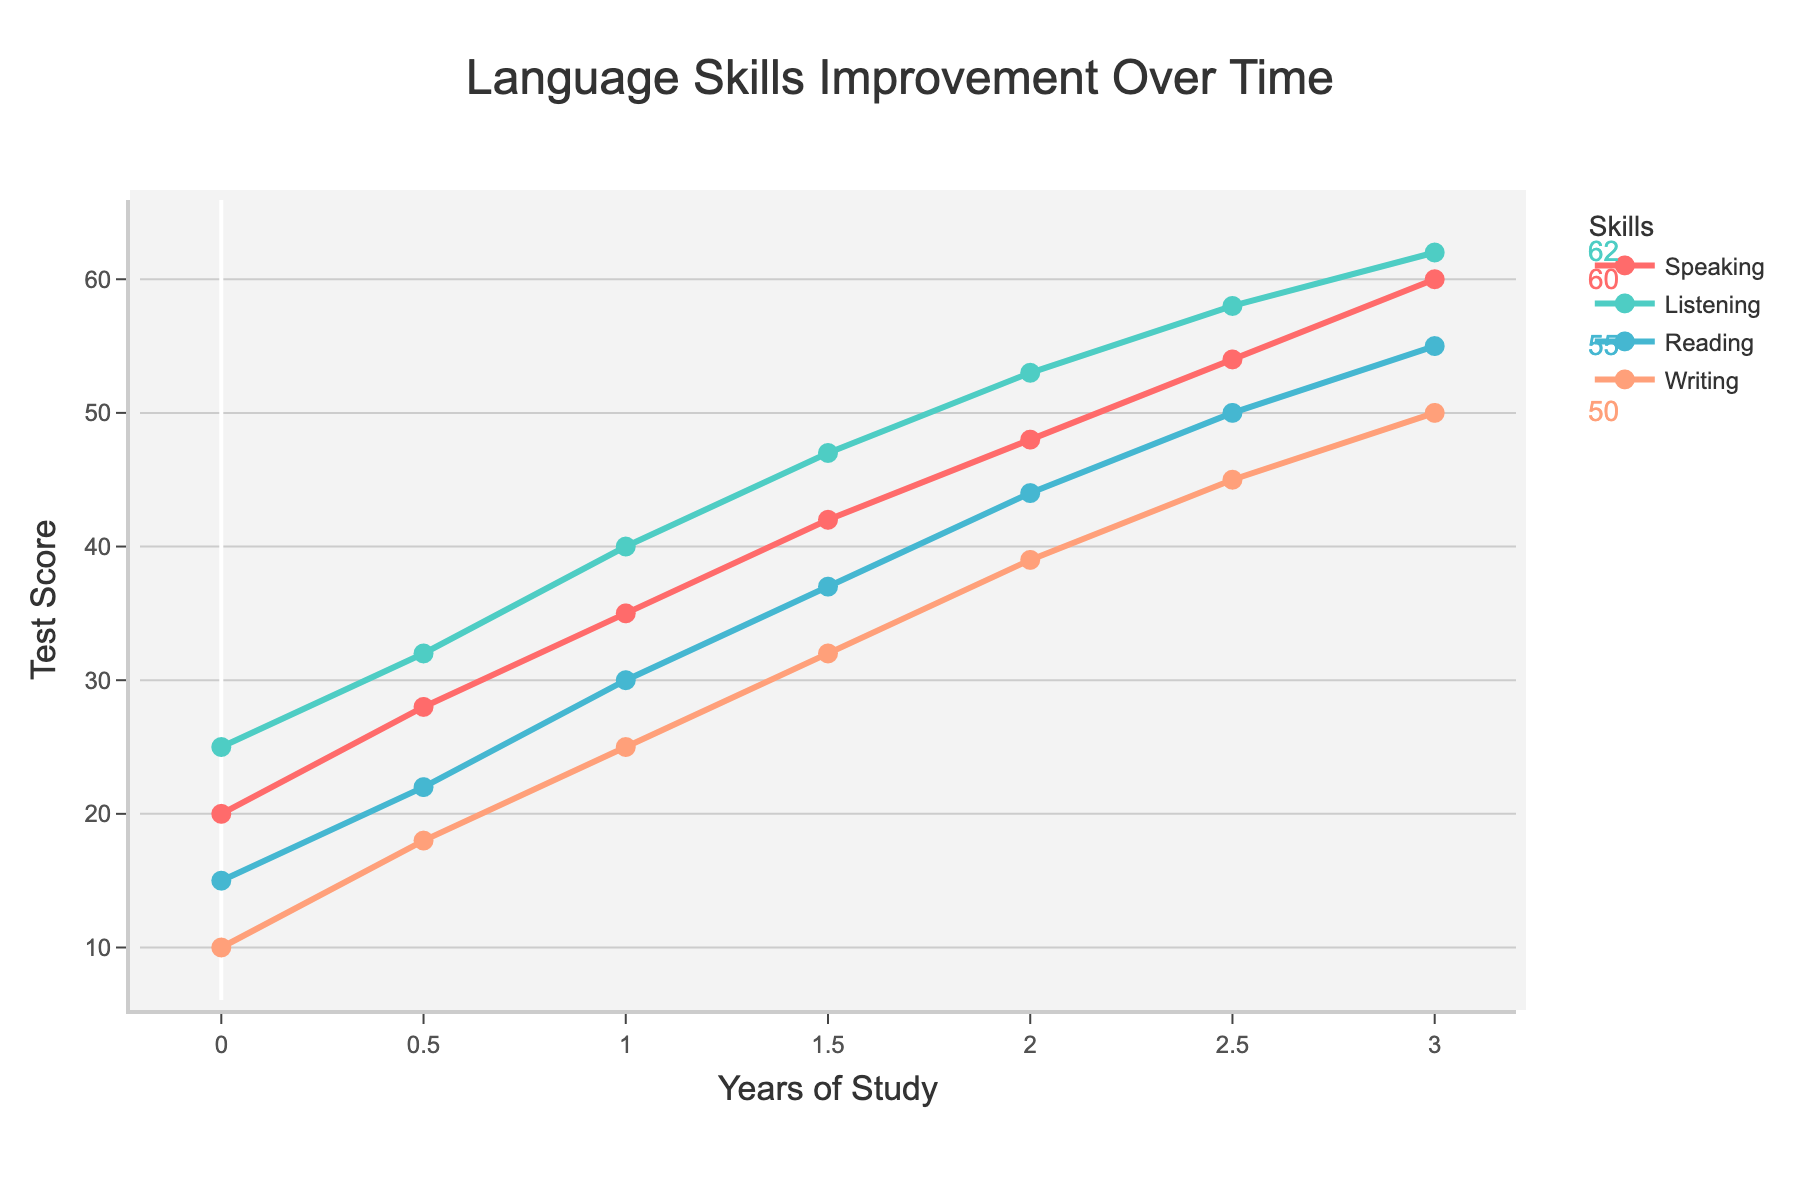Which skill shows the most improvement over the 3 years? Subtract the score at Year 0 from the score at Year 3 for each skill. Speaking: 60-20=40, Listening: 62-25=37, Reading: 55-15=40, Writing: 50-10=40. Speaking, Reading, and Writing all improve by 40 points.
Answer: Speaking, Reading, and Writing Which skill has the highest initial score? Look at the scores at Year 0. Speaking: 20, Listening: 25, Reading: 15, Writing: 10. The highest initial score is in Listening.
Answer: Listening By how many points does Listening improve from Year 1 to Year 2? Subtract the Year 1 score from the Year 2 score for Listening. 53 - 40 = 13 points.
Answer: 13 At Year 2, how much higher is the Reading score compared to the Writing score? Subtract the Year 2 Writing score from the Year 2 Reading score. 44 - 39 = 5 points.
Answer: 5 What is the average score of the Speaking skill across all years? Sum the Speaking scores and divide by the number of years: (20 + 28 + 35 + 42 + 48 + 54 + 60) / 7. 287 / 7 = 41
Answer: 41 Which skill has the steepest growth rate between Year 0 and Year 1? Calculate the difference in scores between Year 0 and Year 1 for each skill: Speaking: 35-20=15, Listening: 40-25=15, Reading: 30-15=15, Writing: 25-10=15. All skills have equal growth rates.
Answer: All skills At what year do both Speaking and Listening scores reach or exceed 40? Identify the year when the Speaking and Listening scores are both 40 or above. Speaking reaches 40 at Year 1.5, Listening reaches 40 at Year 1.
Answer: Year 1.5 What is the total score for all skills combined in Year 1? Sum the scores for all skills in Year 1. Speaking: 35, Listening: 40, Reading: 30, Writing: 25. 35 + 40 + 30 + 25 = 130
Answer: 130 How much does the Writing score increase per year on average? Subtract the initial Writing score from the final Writing score and divide by the number of years: (50 - 10) / 3 = 40 / 3 ≈ 13.33
Answer: 13.33 